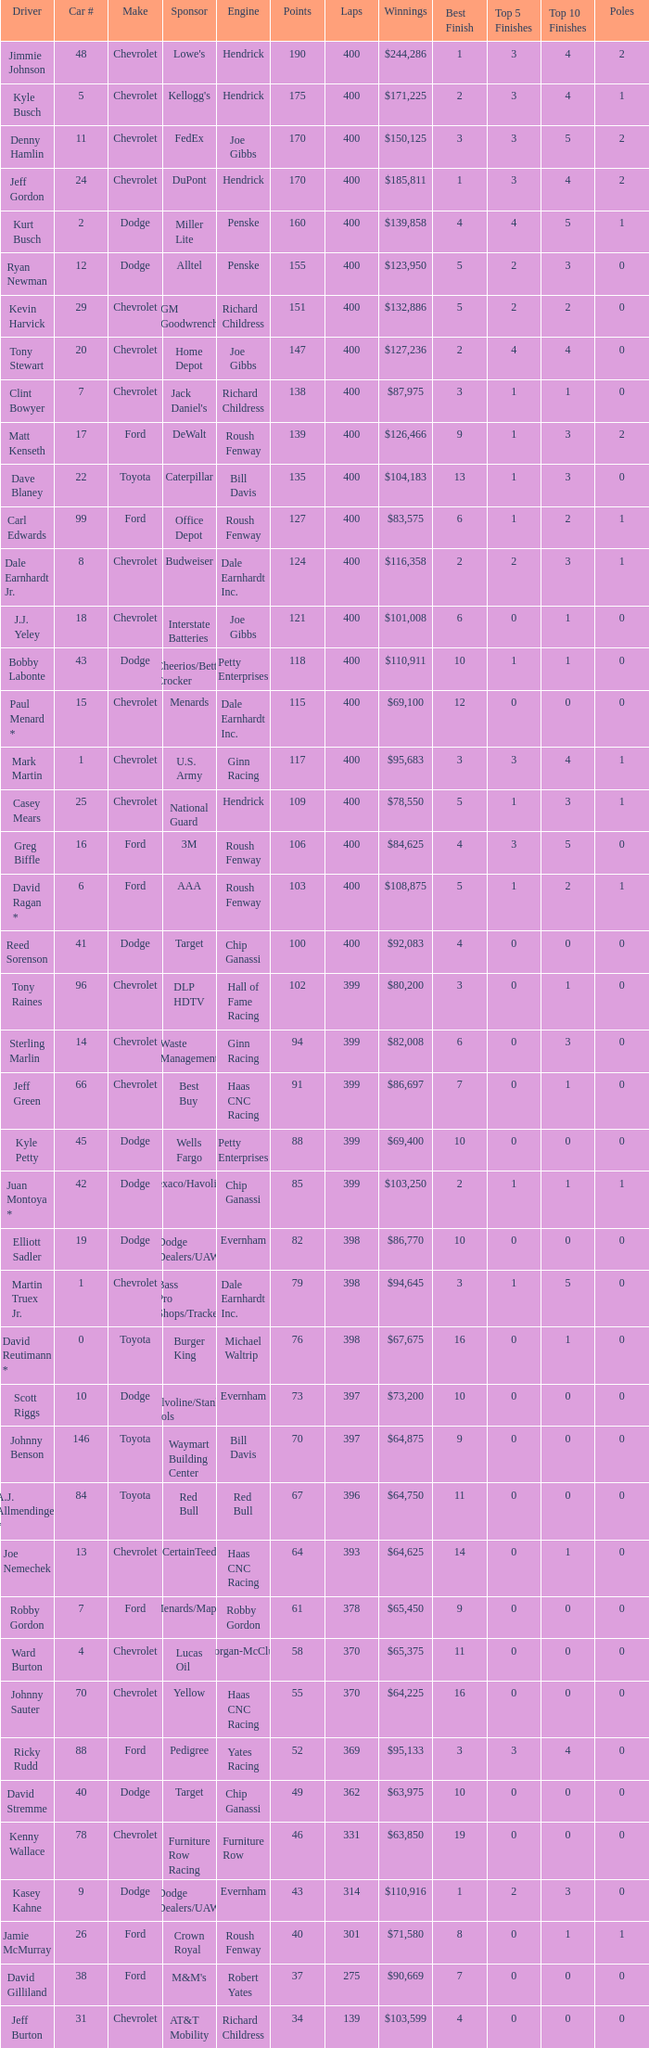What were the winnings for the Chevrolet with a number larger than 29 and scored 102 points? $80,200. 